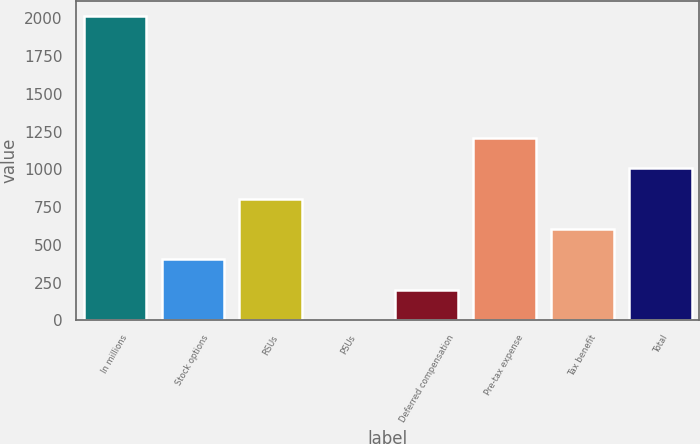Convert chart to OTSL. <chart><loc_0><loc_0><loc_500><loc_500><bar_chart><fcel>In millions<fcel>Stock options<fcel>RSUs<fcel>PSUs<fcel>Deferred compensation<fcel>Pre-tax expense<fcel>Tax benefit<fcel>Total<nl><fcel>2013<fcel>403.4<fcel>805.8<fcel>1<fcel>202.2<fcel>1208.2<fcel>604.6<fcel>1007<nl></chart> 